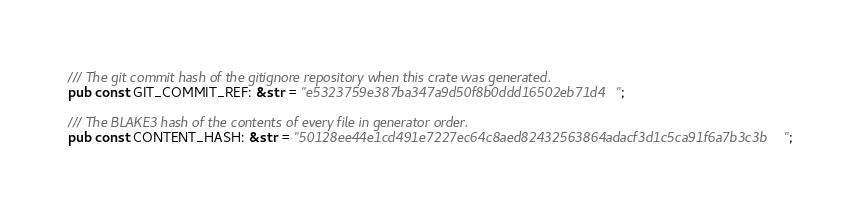Convert code to text. <code><loc_0><loc_0><loc_500><loc_500><_Rust_>
/// The git commit hash of the gitignore repository when this crate was generated.
pub const GIT_COMMIT_REF: &str = "e5323759e387ba347a9d50f8b0ddd16502eb71d4";

/// The BLAKE3 hash of the contents of every file in generator order.
pub const CONTENT_HASH: &str = "50128ee44e1cd491e7227ec64c8aed82432563864adacf3d1c5ca91f6a7b3c3b";
</code> 